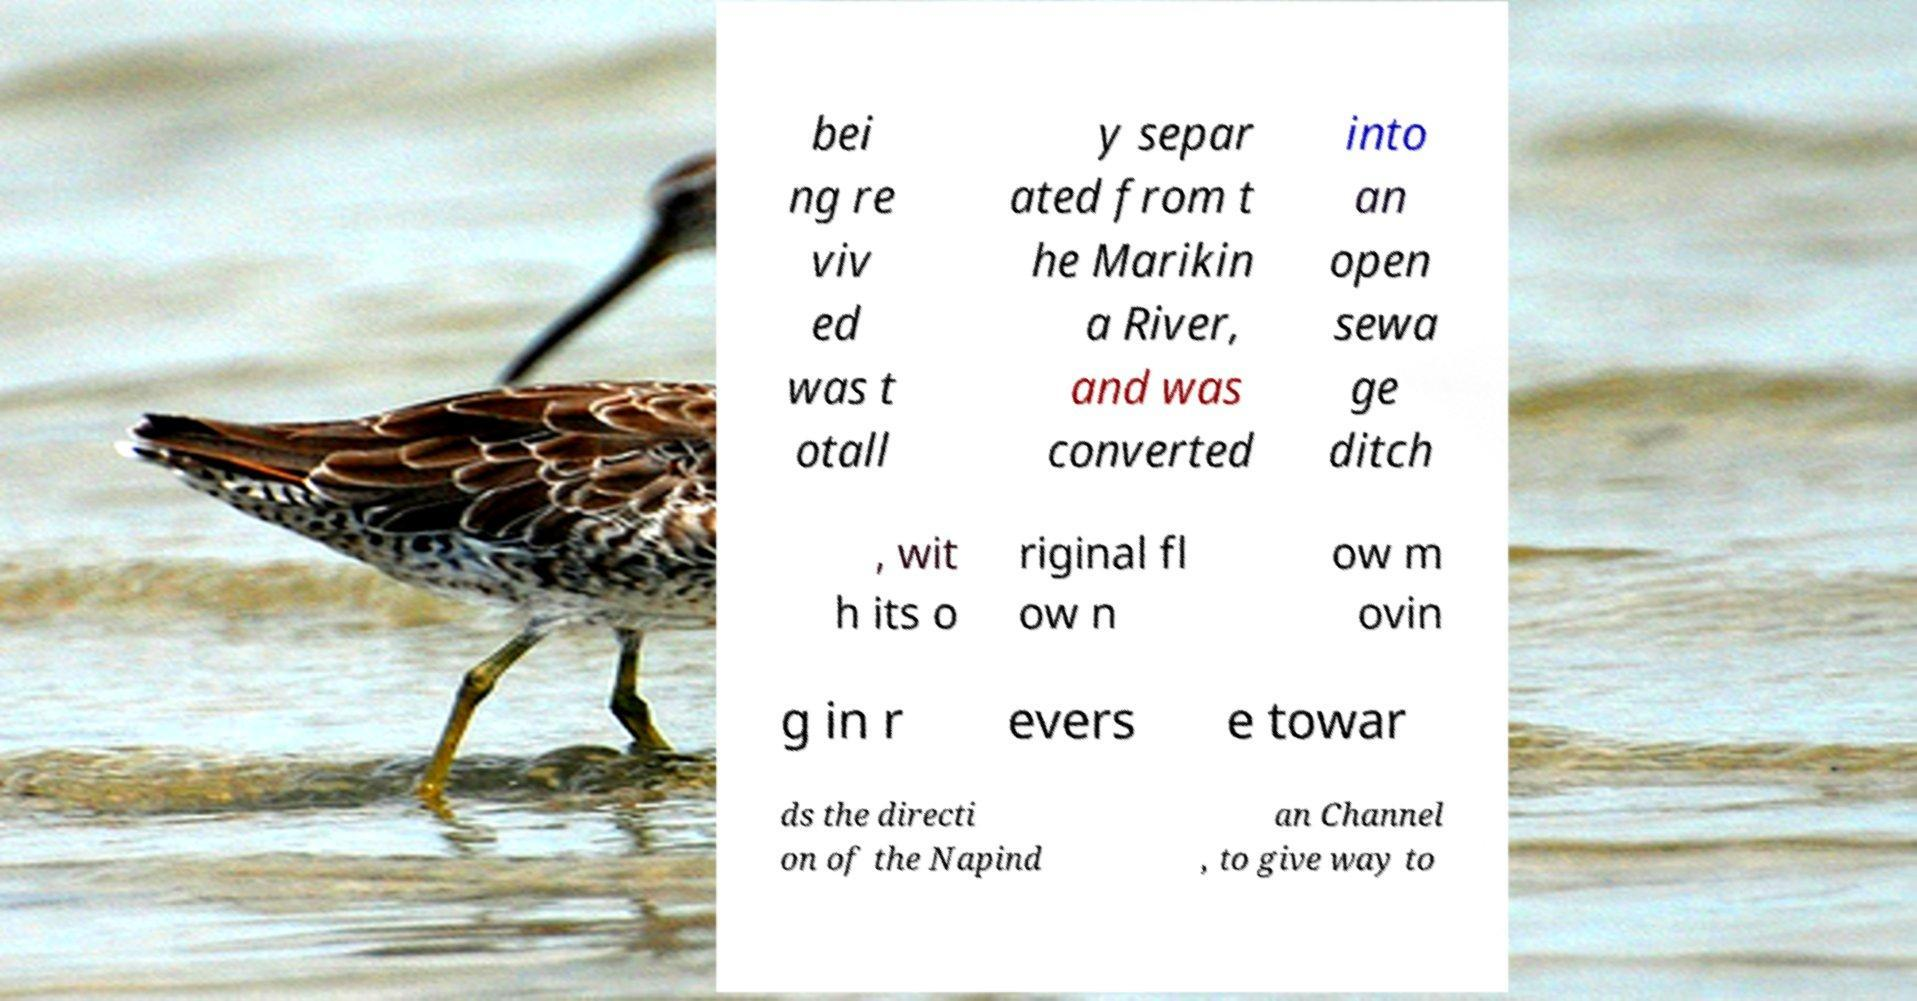For documentation purposes, I need the text within this image transcribed. Could you provide that? bei ng re viv ed was t otall y separ ated from t he Marikin a River, and was converted into an open sewa ge ditch , wit h its o riginal fl ow n ow m ovin g in r evers e towar ds the directi on of the Napind an Channel , to give way to 